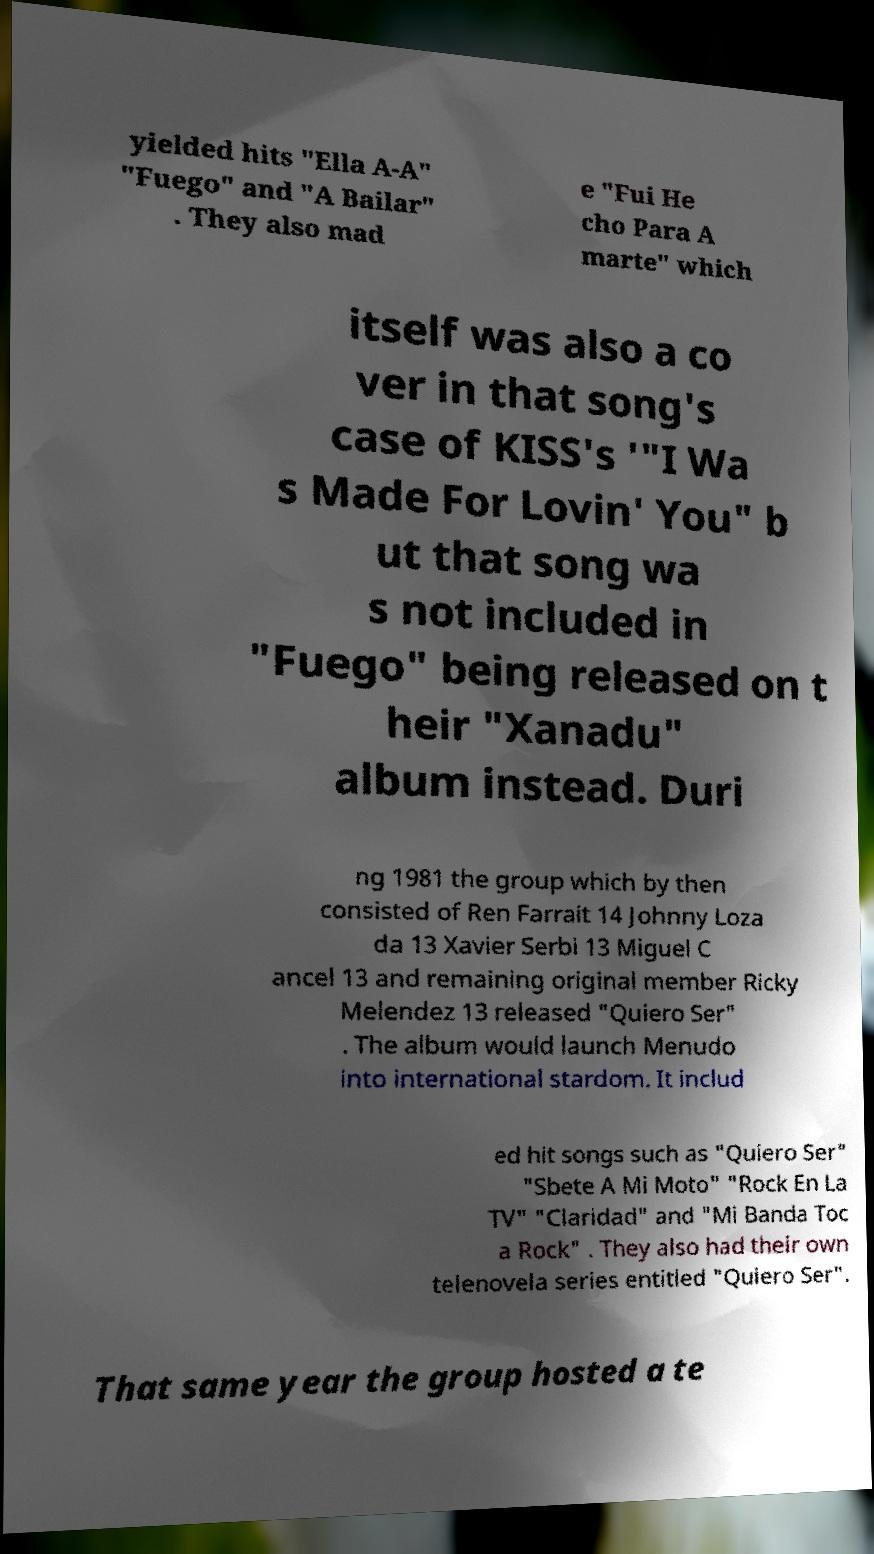Could you assist in decoding the text presented in this image and type it out clearly? yielded hits "Ella A-A" "Fuego" and "A Bailar" . They also mad e "Fui He cho Para A marte" which itself was also a co ver in that song's case of KISS's '"I Wa s Made For Lovin' You" b ut that song wa s not included in "Fuego" being released on t heir "Xanadu" album instead. Duri ng 1981 the group which by then consisted of Ren Farrait 14 Johnny Loza da 13 Xavier Serbi 13 Miguel C ancel 13 and remaining original member Ricky Melendez 13 released "Quiero Ser" . The album would launch Menudo into international stardom. It includ ed hit songs such as "Quiero Ser" "Sbete A Mi Moto" "Rock En La TV" "Claridad" and "Mi Banda Toc a Rock" . They also had their own telenovela series entitled "Quiero Ser". That same year the group hosted a te 